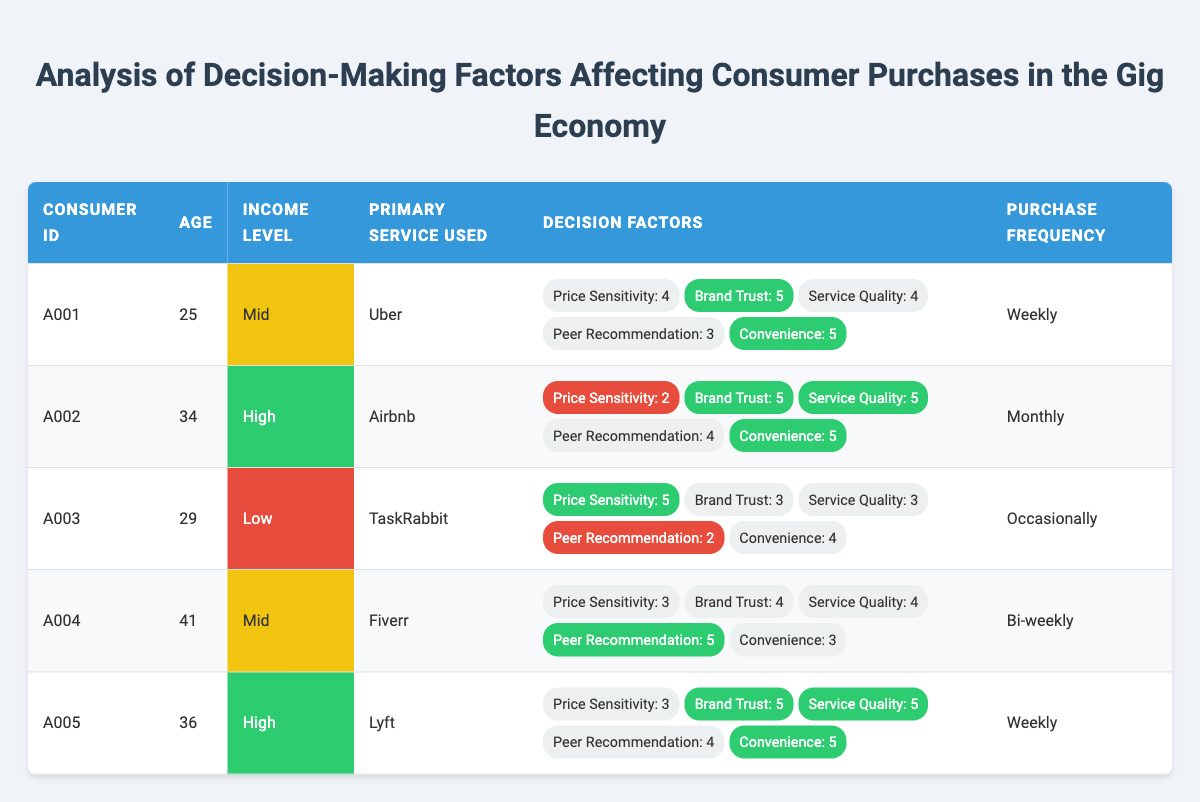What is the age of consumer A003? The table indicates that the age listed for consumer A003 is 29.
Answer: 29 Which consumer has the highest brand trust rating? By examining the brand trust ratings across all consumers, A001, A002, A005 have a rating of 5, making them the highest.
Answer: A001, A002, A005 What is the purchase frequency of consumer A002? The table shows that consumer A002 has a purchase frequency listed as "Monthly."
Answer: Monthly Is consumer A004's primary service used higher or lower in peer recommendation compared to A003? Consumer A004 has a peer recommendation rating of 5, while A003 has a rating of 2. Since 5 is higher than 2, A004 has a higher rating in this factor.
Answer: Higher What is the average price sensitivity rating for consumers aged 30 and above? Consumers A002 (2), A004 (3), and A005 (3) are aged 30 or above. Summing these ratings gives (2+3+3)=8, and averaging by dividing by the number of consumers (3) yields an average of 8/3 which is approximately 2.67.
Answer: 2.67 Does consumer A001 use Lyft as their primary service? The table shows that consumer A001's primary service used is Uber, not Lyft, making the answer false.
Answer: No Which consumer shows the highest convenience rating and what is that rating? By checking the convenience ratings, A001, A002, A005 all have a rating of 5, which is the highest value. Thus, multiple consumers share this highest convenience rating.
Answer: A001, A002, A005 - 5 What is the income level of consumer A005? The table indicates that consumer A005 belongs to the 'High' income level category.
Answer: High How many consumers use Uber as their primary service? The table shows that only one consumer, A001, uses Uber as their primary service.
Answer: 1 Which consumer's decision-making factors have a lower service quality rating, A001 or A004? A001 has a service quality rating of 4 and A004 has a rating of 4 as well. Since both ratings are equal, neither has a lower service quality rating, confirming they are the same.
Answer: They are equal 